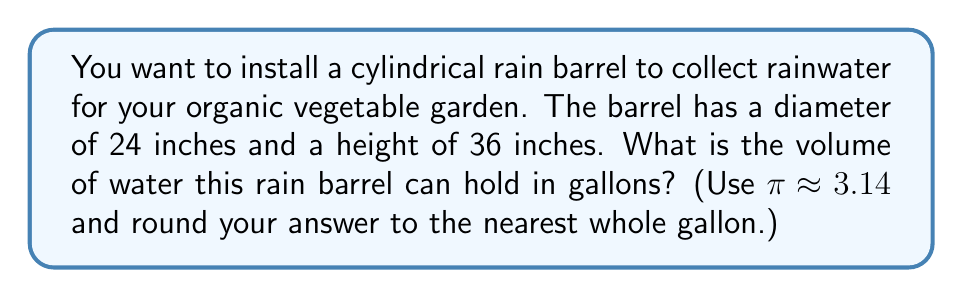Can you solve this math problem? To solve this problem, we'll follow these steps:

1) The volume of a cylinder is given by the formula:
   $$V = πr^2h$$
   where $r$ is the radius and $h$ is the height.

2) We're given the diameter (24 inches), so we need to halve this to get the radius:
   $$r = 24 ÷ 2 = 12 \text{ inches}$$

3) Now we can substitute our values into the formula:
   $$V = π(12\text{ in})^2(36\text{ in})$$
   $$V = 3.14 * 144\text{ in}^2 * 36\text{ in}$$
   $$V = 16,261.44\text{ in}^3$$

4) We need to convert cubic inches to gallons. There are 231 cubic inches in a gallon:
   $$16,261.44\text{ in}^3 * \frac{1\text{ gallon}}{231\text{ in}^3} = 70.40\text{ gallons}$$

5) Rounding to the nearest whole gallon:
   $$70.40\text{ gallons} ≈ 70\text{ gallons}$$

Therefore, the rain barrel can hold approximately 70 gallons of water.
Answer: 70 gallons 